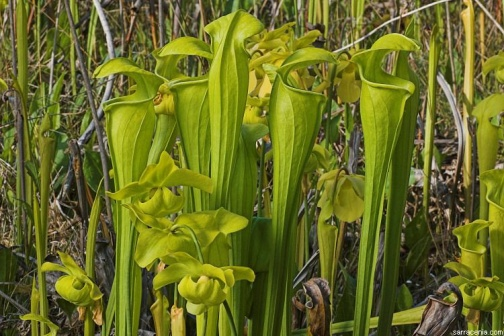Could you describe the environment these plants are in? The environment depicted in the image is a marshy habitat, characterized by water-logged, nutrient-poor soils which are ideal for pitcher plants. The area is filled with tall, brown grasses that provide a contrasting backdrop to the vibrant green pitcher plants. This setting lacks any signs of human presence, suggesting a natural, untouched ecosystem. The light seems to be soft, possibly indicating an overcast day or the time near dawn or dusk. The overall scene conveys a sense of tranquility and the unspoiled beauty of nature. What other types of plants might be found in this marshy area? In addition to pitcher plants, you might find a variety of other plants thriving in this marshy area. Common companions could include sundews and bladderworts, which are also carnivorous plants adapted to nutrient-poor soils. Various species of sedges, rushes, and mosses might be present, contributing to the dense and diverse plant life typical of marshes. Some aquatic or semi-aquatic plants like water lilies or cattails could also be spotted, adding to the biodiversity of this habitat. Imagine there's a tiny village of fairies living among these plants. Describe their day-to-day activities. In the heart of this lush, marshy habitat, imagine a tiny village of fairies flourishing among the pitcher plants. These fairies, each no bigger than a leaf, have their homes nestled within the tubes of the plants, using the bright leaves as protective shelters. As dawn breaks, the fairies emerge to collect dew drops, which they use as drinking water and for their daily potions.

Throughout the day, the fairies flit lightly from plant to plant, pollinating flowers and spreading seeds across the marsh. Their tasks include tending to the plants, ensuring they stay healthy and vibrant, and protecting the area from any pests that might threaten this delicate ecosystem. Some fairies are skilled in healing, using their knowledge of the marsh's flora to create remedies for any sick or injured creatures.

As the sun starts to set, the fairies gather near clusters of tall grasses, sharing stories and singing songs that resonate through the marsh. These musical evenings strengthen their bonds and ensure harmony in their small community. The glow of bioluminescent fungi, carefully cultivated by the fairies, illuminates their night-time activities, creating a magical ambiance in the marsh. I wonder, what kind of animals might interact with these pitcher plants? In this marshy area, a variety of animals might interact with the pitcher plants. Insects like flies, ants, and beetles are the primary visitors, attracted by the plants' nectar and bright coloration. Unknowingly, these insects often fall into the pitchers and become trapped, providing the plants with essential nutrients.

Small amphibians, such as frogs and salamanders, might be found resting on the broader leaves, taking advantage of the moisture and shade provided by the plants. Birds, particularly those that feed on insects, might occasionally hover around the area, drawn by the abundance of insect prey.

Interestingly, some small mammals, like shrews, may hunt for insects around the pitcher plants or even drink the fluid inside the pitchers. These interactions highlight the complex food web and interdependence of species within this marshy ecosystem. Do you think any legends or folklore are associated with pitcher plants in various cultures? Absolutely, many cultures around the world have developed legends and folklore surrounding pitcher plants. In some indigenous cultures, pitcher plants are considered mystical due to their unusual appearance and carnivorous nature. It is believed that the spirits of ancestors inhabit these plants and protect the marshlands.

In Southeast Asia, there are tales of pitcher plants capturing not just insects, but also spirits leading the unwary away from dangerous activities. The fluid inside the pitchers is thought to possess healing properties, and local shamans might use it in their rituals.

Another legend from the rainforest region speaks of a giant pitcher plant tended by a forest guardian. This plant is said to lure in those who seek to harm the forest, trapping them until they repent and pledge to protect the environment.

In Victorian England, pitcher plants fascinated naturalists and inspired various gothic tales. Some stories spoke of enchanted gardens where the plants could ensnare more than just insects, leading to ghostly or otherworldly encounters.

These legends and stories reflect the mystique and reverence that pitcher plants inspire, highlighting their unique and captivating role in the natural world. 